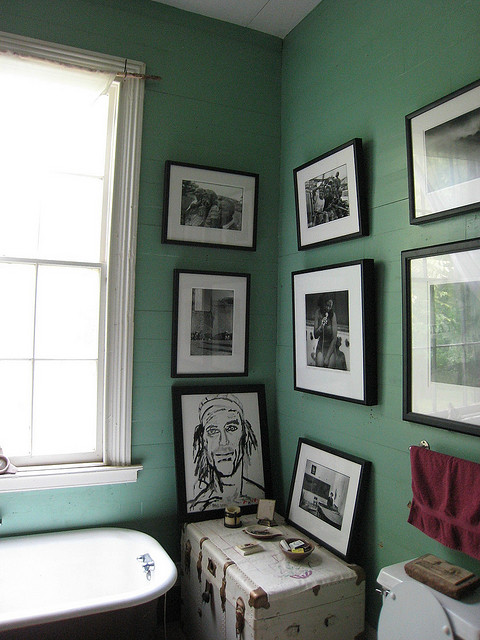<image>What sort of photograph dominates the wall to the right of the toilet? I don't know what sort of photograph dominates the wall to the right of the toilet. It can be 'retro', 'self portrait', 'nature', 'black and white', 'caricature', etc. What sort of photograph dominates the wall to the right of the toilet? It is unknown what sort of photograph dominates the wall to the right of the toilet. 